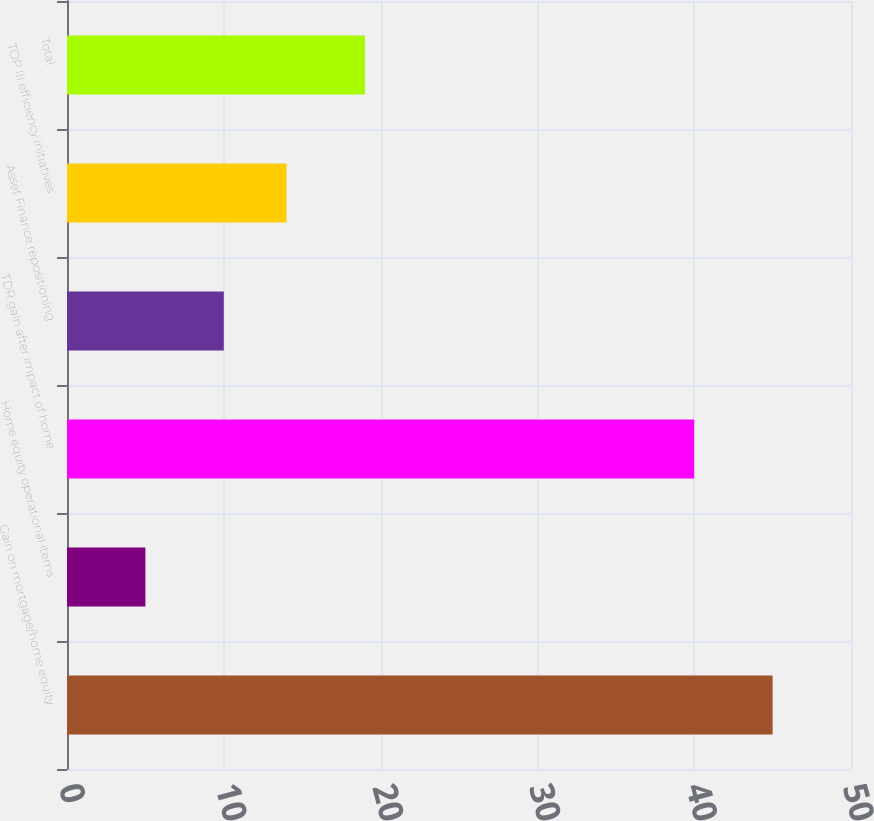Convert chart to OTSL. <chart><loc_0><loc_0><loc_500><loc_500><bar_chart><fcel>Gain on mortgage/home equity<fcel>Home equity operational items<fcel>TDR gain after impact of home<fcel>Asset Finance repositioning<fcel>TOP III efficiency initiatives<fcel>Total<nl><fcel>45<fcel>5<fcel>40<fcel>10<fcel>14<fcel>19<nl></chart> 